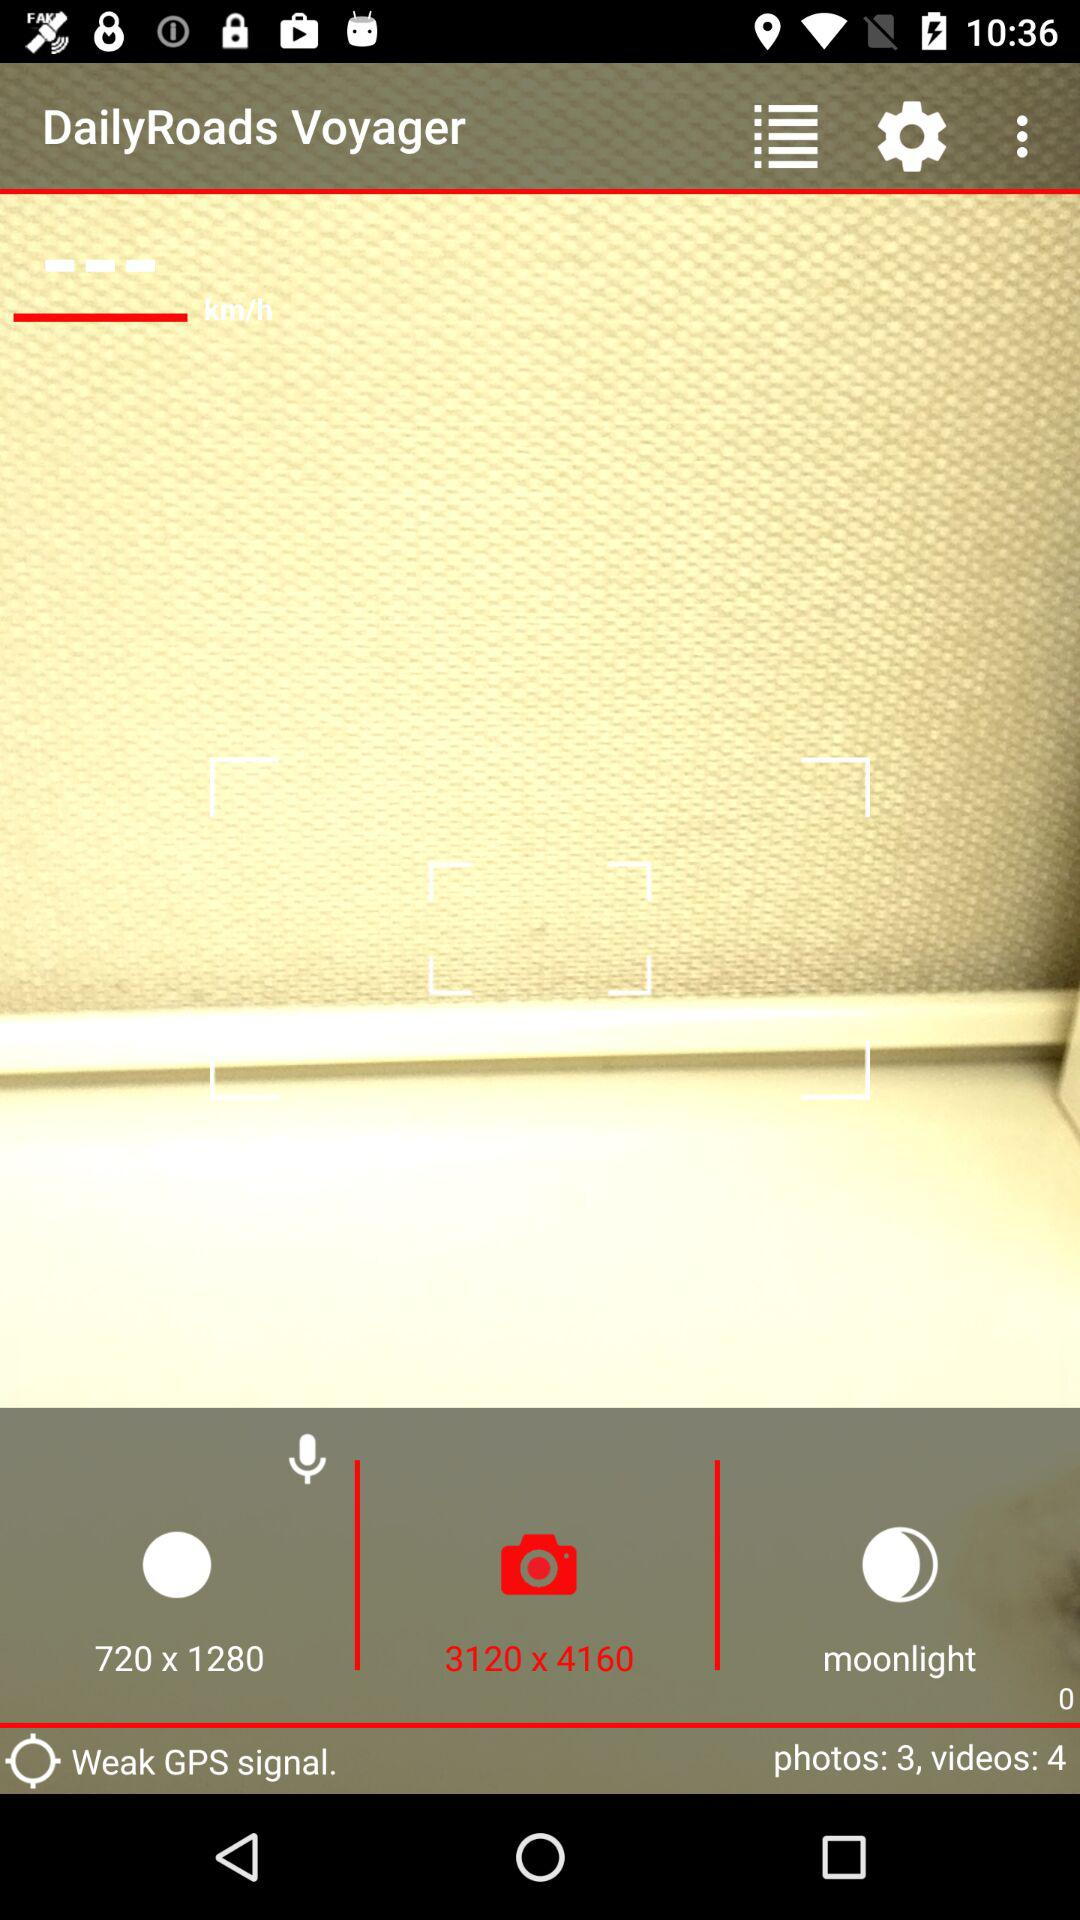What is the GPS signal strength? The GPS signal strength is "Weak". 